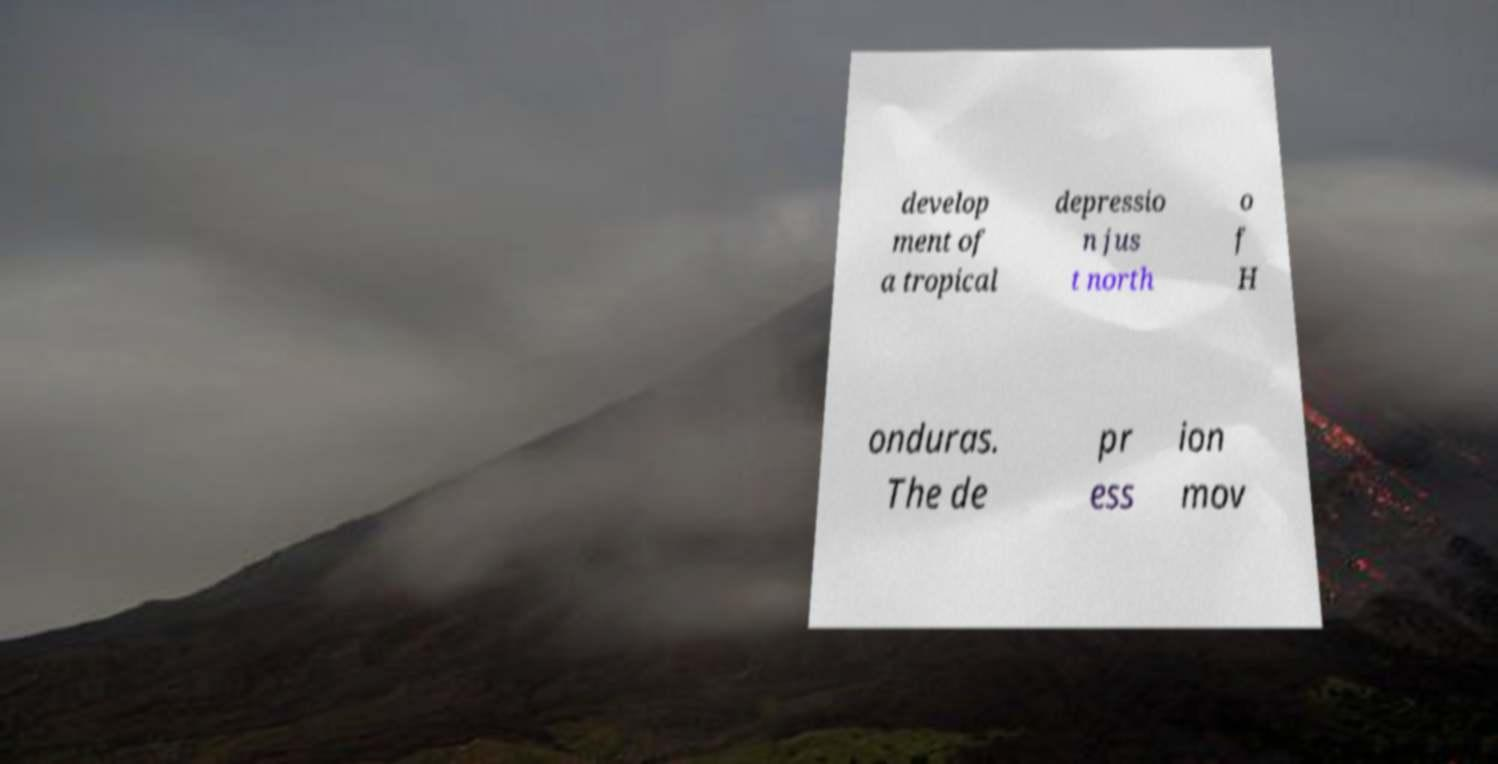I need the written content from this picture converted into text. Can you do that? develop ment of a tropical depressio n jus t north o f H onduras. The de pr ess ion mov 